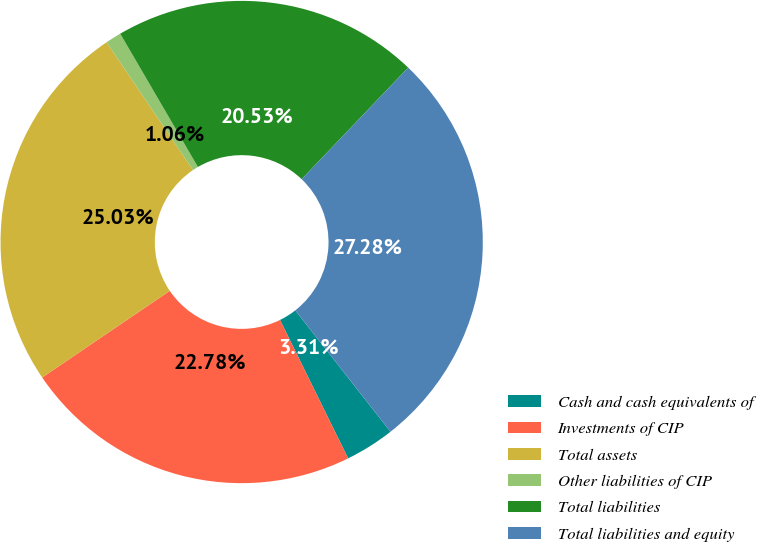<chart> <loc_0><loc_0><loc_500><loc_500><pie_chart><fcel>Cash and cash equivalents of<fcel>Investments of CIP<fcel>Total assets<fcel>Other liabilities of CIP<fcel>Total liabilities<fcel>Total liabilities and equity<nl><fcel>3.31%<fcel>22.78%<fcel>25.03%<fcel>1.06%<fcel>20.53%<fcel>27.28%<nl></chart> 